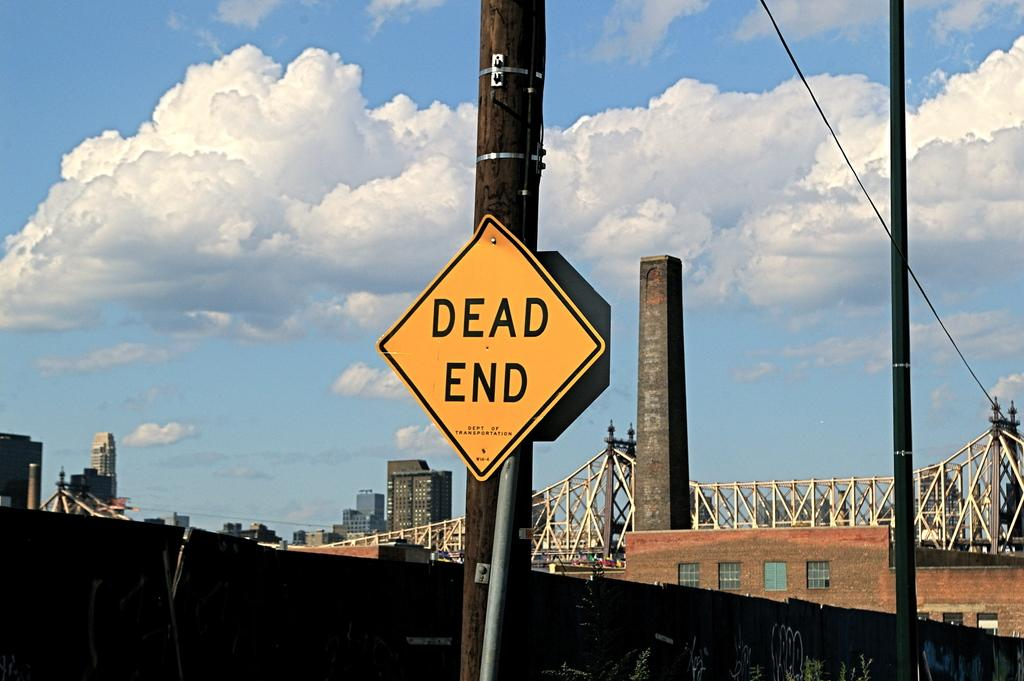<image>
Write a terse but informative summary of the picture. Road sign with Dead end wrote in the middle. 